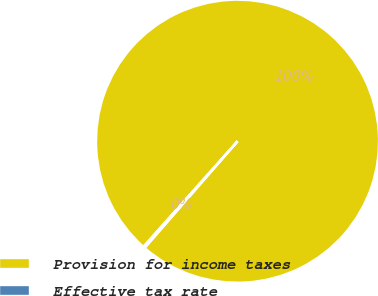<chart> <loc_0><loc_0><loc_500><loc_500><pie_chart><fcel>Provision for income taxes<fcel>Effective tax rate<nl><fcel>99.81%<fcel>0.19%<nl></chart> 